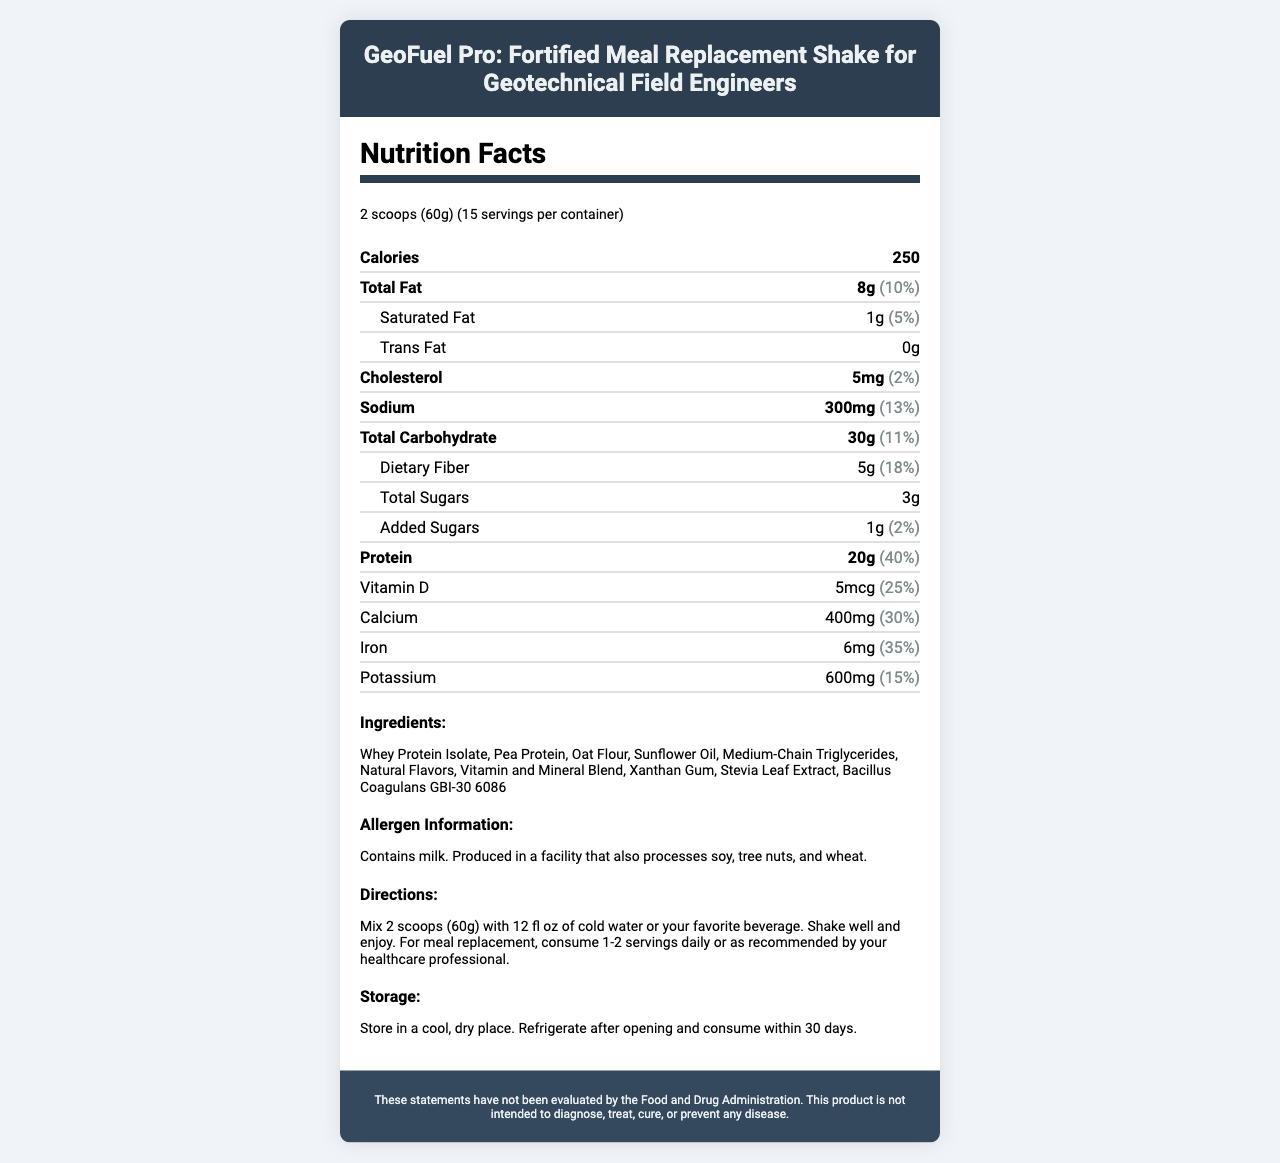what is the serving size of GeoFuel Pro? The serving size is clearly mentioned at the beginning of the document as "2 scoops (60g)".
Answer: 2 scoops (60g) how many calories are in each serving? The calories per serving are listed under the nutrition facts section as "250".
Answer: 250 which vitamins have a daily value of 100% per serving? The vitamins and minerals with daily values of 100% per serving are listed in the nutrition facts section and include Thiamin, Riboflavin, Niacin, Vitamin B6, Folate, Vitamin B12, Biotin, Pantothenic Acid, Iodine, Zinc, Selenium, Copper, Manganese, Chromium, and Molybdenum.
Answer: Thiamin, Riboflavin, Niacin, Vitamin B6, Folate, Vitamin B12, Biotin, Pantothenic Acid, Iodine, Zinc, Selenium, Copper, Manganese, Chromium, Molybdenum how much protein is in one serving? The amount of protein per serving can be found in the nutrition facts section as "Protein: 20g (40% DV)".
Answer: 20g what are the directions for consuming GeoFuel Pro? The directions can be found in the directions section of the document.
Answer: Mix 2 scoops (60g) with 12 fl oz of cold water or your favorite beverage. Shake well and enjoy. For meal replacement, consume 1-2 servings daily or as recommended by your healthcare professional. how much saturated fat is in a serving? The saturated fat content per serving is listed in the nutrition facts section as "Saturated Fat: 1g (5% DV)".
Answer: 1g which ingredient is first on the list? The first ingredient listed in the ingredients section is "Whey Protein Isolate".
Answer: Whey Protein Isolate what is the total number of servings per container? The total number of servings per container is noted at the top of the nutrition facts section as "15 servings per container".
Answer: 15 what is the allergen information for GeoFuel Pro? The allergen information is provided in a specific section stating it contains milk and is produced in a facility processing soy, tree nuts, and wheat.
Answer: Contains milk. Produced in a facility that also processes soy, tree nuts, and wheat. how much calcium is in a serving? The amount of calcium per serving is listed under the nutrition facts as "Calcium: 400mg (30% DV)".
Answer: 400mg which of the following vitamins is NOT included in GeoFuel Pro? A. Vitamin B6 B. Vitamin K C. Vitamin B16 D. Vitamin C The document lists many vitamins, but Vitamin B16 is not among them. The listed vitamins include B6, K, and C.
Answer: C. Vitamin B16 how should GeoFuel Pro be stored after opening? A. In a pantry B. Refrigerate C. In a freezer The storage instructions, listed at the end of the directions, indicate that the product should be refrigerated after opening and consumed within 30 days.
Answer: B. Refrigerate does GeoFuel Pro contain trans fat? The document lists the trans fat content as "0g", which means the product contains no trans fat.
Answer: No summarize the main components of GeoFuel Pro. This summary covers the main idea, encapsulating the product's purpose, key nutritional information, ingredients, and usage instructions.
Answer: GeoFuel Pro is a fortified meal replacement shake for geotechnical field engineers, offering a comprehensive nutritional profile with 250 calories per serving, 20g of protein, an array of vitamins and minerals, and a mix of whey protein isolate, pea protein, and oat flour. It has specific storage and allergen information, along with detailed directions for use. how much daily percentage of vitamin C does one serving provide? The nutrition facts section lists the daily value of Vitamin C per serving as "70%".
Answer: 70% is this product intended to diagnose, treat, cure, or prevent any disease? The disclaimer at the end of the document explicitly states that the product is not intended to diagnose, treat, cure, or prevent any disease.
Answer: No what is the form of added sugars in the product? The amount of added sugars is mentioned (1g), but the exact form of added sugars is not specified in the document.
Answer: Cannot be determined 